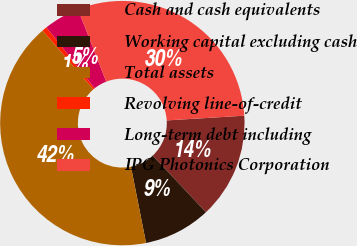<chart> <loc_0><loc_0><loc_500><loc_500><pie_chart><fcel>Cash and cash equivalents<fcel>Working capital excluding cash<fcel>Total assets<fcel>Revolving line-of-credit<fcel>Long-term debt including<fcel>IPG Photonics Corporation<nl><fcel>13.98%<fcel>8.88%<fcel>41.79%<fcel>0.65%<fcel>4.76%<fcel>29.94%<nl></chart> 